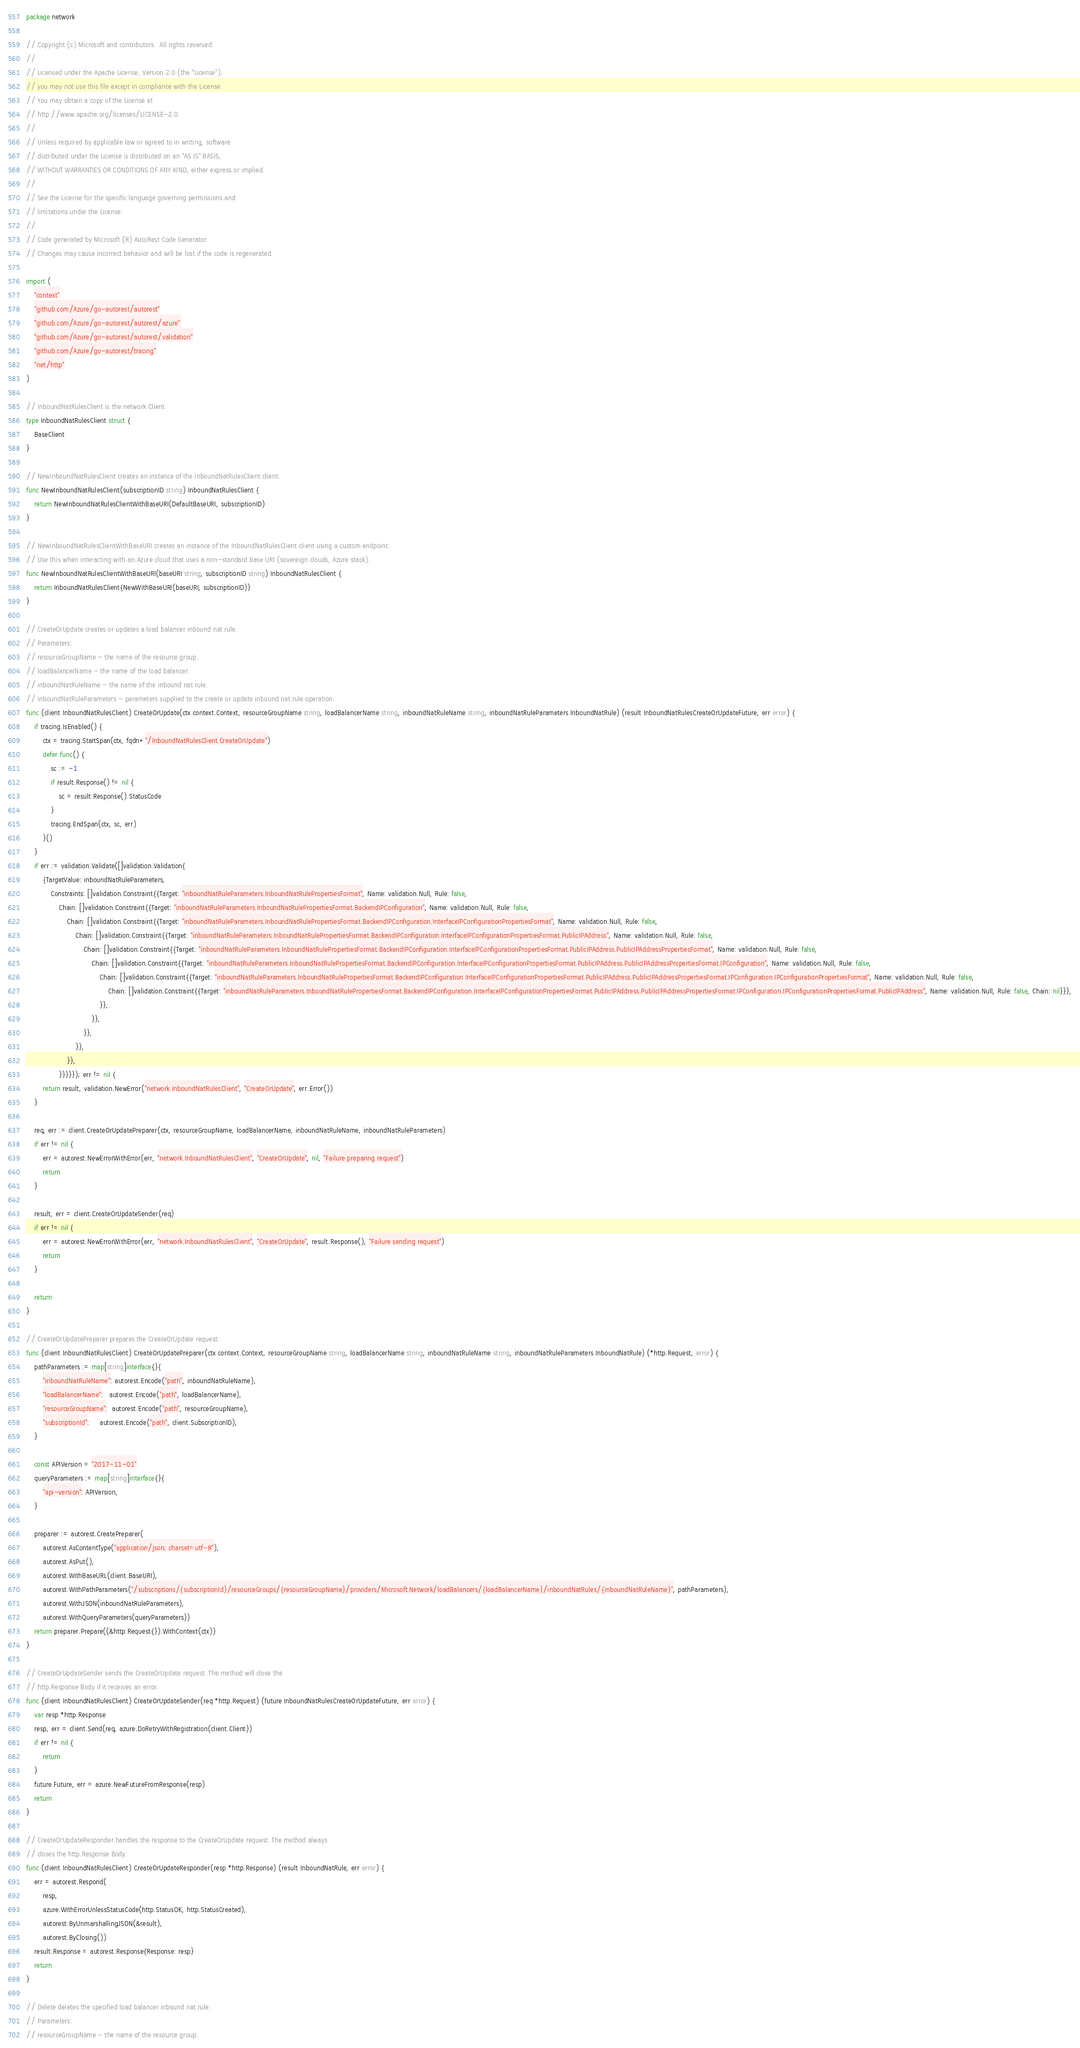Convert code to text. <code><loc_0><loc_0><loc_500><loc_500><_Go_>package network

// Copyright (c) Microsoft and contributors.  All rights reserved.
//
// Licensed under the Apache License, Version 2.0 (the "License");
// you may not use this file except in compliance with the License.
// You may obtain a copy of the License at
// http://www.apache.org/licenses/LICENSE-2.0
//
// Unless required by applicable law or agreed to in writing, software
// distributed under the License is distributed on an "AS IS" BASIS,
// WITHOUT WARRANTIES OR CONDITIONS OF ANY KIND, either express or implied.
//
// See the License for the specific language governing permissions and
// limitations under the License.
//
// Code generated by Microsoft (R) AutoRest Code Generator.
// Changes may cause incorrect behavior and will be lost if the code is regenerated.

import (
	"context"
	"github.com/Azure/go-autorest/autorest"
	"github.com/Azure/go-autorest/autorest/azure"
	"github.com/Azure/go-autorest/autorest/validation"
	"github.com/Azure/go-autorest/tracing"
	"net/http"
)

// InboundNatRulesClient is the network Client
type InboundNatRulesClient struct {
	BaseClient
}

// NewInboundNatRulesClient creates an instance of the InboundNatRulesClient client.
func NewInboundNatRulesClient(subscriptionID string) InboundNatRulesClient {
	return NewInboundNatRulesClientWithBaseURI(DefaultBaseURI, subscriptionID)
}

// NewInboundNatRulesClientWithBaseURI creates an instance of the InboundNatRulesClient client using a custom endpoint.
// Use this when interacting with an Azure cloud that uses a non-standard base URI (sovereign clouds, Azure stack).
func NewInboundNatRulesClientWithBaseURI(baseURI string, subscriptionID string) InboundNatRulesClient {
	return InboundNatRulesClient{NewWithBaseURI(baseURI, subscriptionID)}
}

// CreateOrUpdate creates or updates a load balancer inbound nat rule.
// Parameters:
// resourceGroupName - the name of the resource group.
// loadBalancerName - the name of the load balancer.
// inboundNatRuleName - the name of the inbound nat rule.
// inboundNatRuleParameters - parameters supplied to the create or update inbound nat rule operation.
func (client InboundNatRulesClient) CreateOrUpdate(ctx context.Context, resourceGroupName string, loadBalancerName string, inboundNatRuleName string, inboundNatRuleParameters InboundNatRule) (result InboundNatRulesCreateOrUpdateFuture, err error) {
	if tracing.IsEnabled() {
		ctx = tracing.StartSpan(ctx, fqdn+"/InboundNatRulesClient.CreateOrUpdate")
		defer func() {
			sc := -1
			if result.Response() != nil {
				sc = result.Response().StatusCode
			}
			tracing.EndSpan(ctx, sc, err)
		}()
	}
	if err := validation.Validate([]validation.Validation{
		{TargetValue: inboundNatRuleParameters,
			Constraints: []validation.Constraint{{Target: "inboundNatRuleParameters.InboundNatRulePropertiesFormat", Name: validation.Null, Rule: false,
				Chain: []validation.Constraint{{Target: "inboundNatRuleParameters.InboundNatRulePropertiesFormat.BackendIPConfiguration", Name: validation.Null, Rule: false,
					Chain: []validation.Constraint{{Target: "inboundNatRuleParameters.InboundNatRulePropertiesFormat.BackendIPConfiguration.InterfaceIPConfigurationPropertiesFormat", Name: validation.Null, Rule: false,
						Chain: []validation.Constraint{{Target: "inboundNatRuleParameters.InboundNatRulePropertiesFormat.BackendIPConfiguration.InterfaceIPConfigurationPropertiesFormat.PublicIPAddress", Name: validation.Null, Rule: false,
							Chain: []validation.Constraint{{Target: "inboundNatRuleParameters.InboundNatRulePropertiesFormat.BackendIPConfiguration.InterfaceIPConfigurationPropertiesFormat.PublicIPAddress.PublicIPAddressPropertiesFormat", Name: validation.Null, Rule: false,
								Chain: []validation.Constraint{{Target: "inboundNatRuleParameters.InboundNatRulePropertiesFormat.BackendIPConfiguration.InterfaceIPConfigurationPropertiesFormat.PublicIPAddress.PublicIPAddressPropertiesFormat.IPConfiguration", Name: validation.Null, Rule: false,
									Chain: []validation.Constraint{{Target: "inboundNatRuleParameters.InboundNatRulePropertiesFormat.BackendIPConfiguration.InterfaceIPConfigurationPropertiesFormat.PublicIPAddress.PublicIPAddressPropertiesFormat.IPConfiguration.IPConfigurationPropertiesFormat", Name: validation.Null, Rule: false,
										Chain: []validation.Constraint{{Target: "inboundNatRuleParameters.InboundNatRulePropertiesFormat.BackendIPConfiguration.InterfaceIPConfigurationPropertiesFormat.PublicIPAddress.PublicIPAddressPropertiesFormat.IPConfiguration.IPConfigurationPropertiesFormat.PublicIPAddress", Name: validation.Null, Rule: false, Chain: nil}}},
									}},
								}},
							}},
						}},
					}},
				}}}}}); err != nil {
		return result, validation.NewError("network.InboundNatRulesClient", "CreateOrUpdate", err.Error())
	}

	req, err := client.CreateOrUpdatePreparer(ctx, resourceGroupName, loadBalancerName, inboundNatRuleName, inboundNatRuleParameters)
	if err != nil {
		err = autorest.NewErrorWithError(err, "network.InboundNatRulesClient", "CreateOrUpdate", nil, "Failure preparing request")
		return
	}

	result, err = client.CreateOrUpdateSender(req)
	if err != nil {
		err = autorest.NewErrorWithError(err, "network.InboundNatRulesClient", "CreateOrUpdate", result.Response(), "Failure sending request")
		return
	}

	return
}

// CreateOrUpdatePreparer prepares the CreateOrUpdate request.
func (client InboundNatRulesClient) CreateOrUpdatePreparer(ctx context.Context, resourceGroupName string, loadBalancerName string, inboundNatRuleName string, inboundNatRuleParameters InboundNatRule) (*http.Request, error) {
	pathParameters := map[string]interface{}{
		"inboundNatRuleName": autorest.Encode("path", inboundNatRuleName),
		"loadBalancerName":   autorest.Encode("path", loadBalancerName),
		"resourceGroupName":  autorest.Encode("path", resourceGroupName),
		"subscriptionId":     autorest.Encode("path", client.SubscriptionID),
	}

	const APIVersion = "2017-11-01"
	queryParameters := map[string]interface{}{
		"api-version": APIVersion,
	}

	preparer := autorest.CreatePreparer(
		autorest.AsContentType("application/json; charset=utf-8"),
		autorest.AsPut(),
		autorest.WithBaseURL(client.BaseURI),
		autorest.WithPathParameters("/subscriptions/{subscriptionId}/resourceGroups/{resourceGroupName}/providers/Microsoft.Network/loadBalancers/{loadBalancerName}/inboundNatRules/{inboundNatRuleName}", pathParameters),
		autorest.WithJSON(inboundNatRuleParameters),
		autorest.WithQueryParameters(queryParameters))
	return preparer.Prepare((&http.Request{}).WithContext(ctx))
}

// CreateOrUpdateSender sends the CreateOrUpdate request. The method will close the
// http.Response Body if it receives an error.
func (client InboundNatRulesClient) CreateOrUpdateSender(req *http.Request) (future InboundNatRulesCreateOrUpdateFuture, err error) {
	var resp *http.Response
	resp, err = client.Send(req, azure.DoRetryWithRegistration(client.Client))
	if err != nil {
		return
	}
	future.Future, err = azure.NewFutureFromResponse(resp)
	return
}

// CreateOrUpdateResponder handles the response to the CreateOrUpdate request. The method always
// closes the http.Response Body.
func (client InboundNatRulesClient) CreateOrUpdateResponder(resp *http.Response) (result InboundNatRule, err error) {
	err = autorest.Respond(
		resp,
		azure.WithErrorUnlessStatusCode(http.StatusOK, http.StatusCreated),
		autorest.ByUnmarshallingJSON(&result),
		autorest.ByClosing())
	result.Response = autorest.Response{Response: resp}
	return
}

// Delete deletes the specified load balancer inbound nat rule.
// Parameters:
// resourceGroupName - the name of the resource group.</code> 